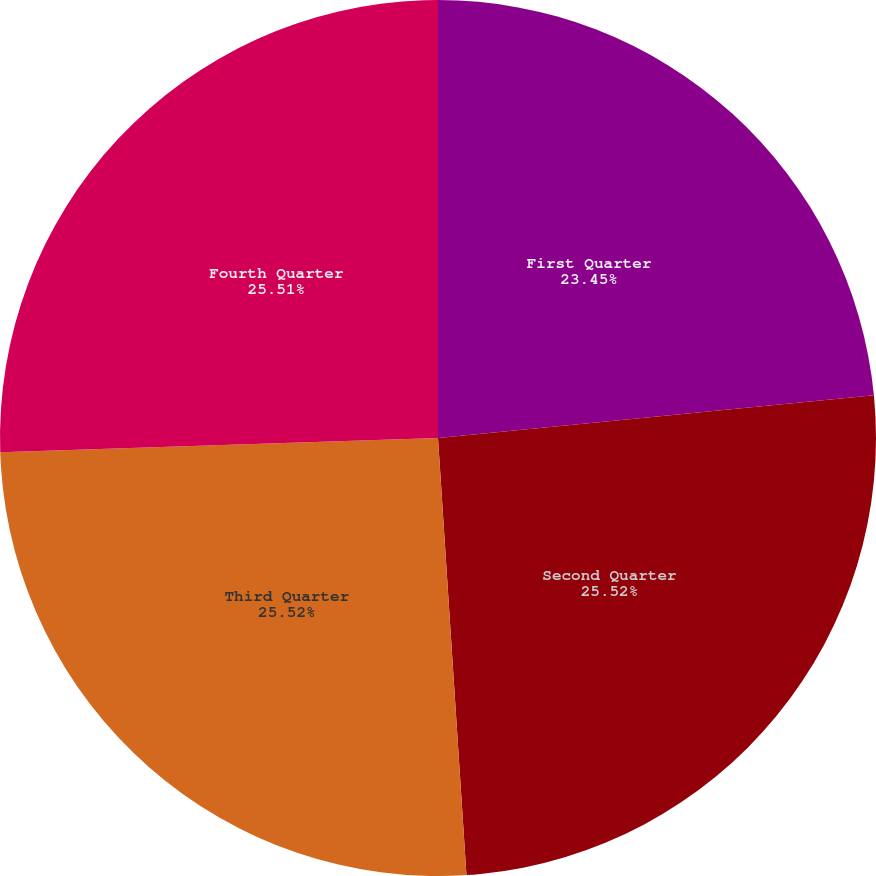Convert chart. <chart><loc_0><loc_0><loc_500><loc_500><pie_chart><fcel>First Quarter<fcel>Second Quarter<fcel>Third Quarter<fcel>Fourth Quarter<nl><fcel>23.45%<fcel>25.52%<fcel>25.52%<fcel>25.52%<nl></chart> 